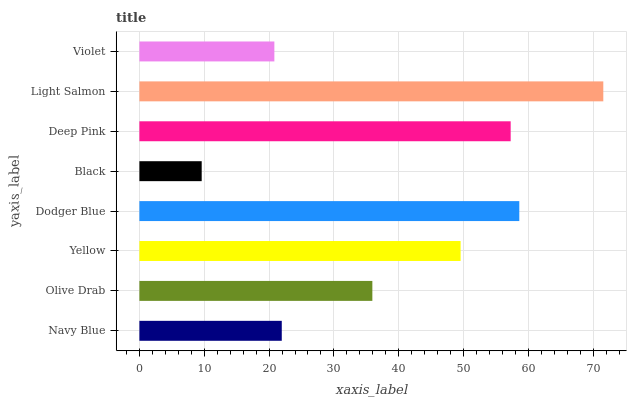Is Black the minimum?
Answer yes or no. Yes. Is Light Salmon the maximum?
Answer yes or no. Yes. Is Olive Drab the minimum?
Answer yes or no. No. Is Olive Drab the maximum?
Answer yes or no. No. Is Olive Drab greater than Navy Blue?
Answer yes or no. Yes. Is Navy Blue less than Olive Drab?
Answer yes or no. Yes. Is Navy Blue greater than Olive Drab?
Answer yes or no. No. Is Olive Drab less than Navy Blue?
Answer yes or no. No. Is Yellow the high median?
Answer yes or no. Yes. Is Olive Drab the low median?
Answer yes or no. Yes. Is Dodger Blue the high median?
Answer yes or no. No. Is Violet the low median?
Answer yes or no. No. 